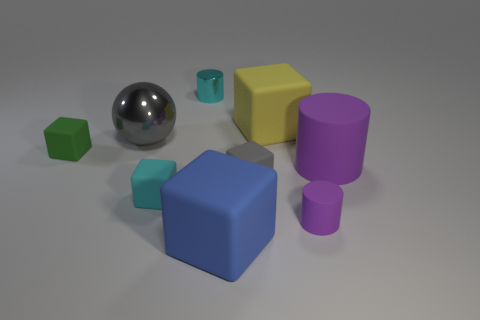Subtract all purple cylinders. How many cylinders are left? 1 Subtract all large yellow blocks. How many blocks are left? 4 Subtract 1 cylinders. How many cylinders are left? 2 Subtract all purple spheres. Subtract all green cylinders. How many spheres are left? 1 Subtract all gray cylinders. How many gray blocks are left? 1 Subtract all small brown shiny things. Subtract all tiny rubber cubes. How many objects are left? 6 Add 4 small cyan cylinders. How many small cyan cylinders are left? 5 Add 4 tiny matte blocks. How many tiny matte blocks exist? 7 Subtract 0 blue cylinders. How many objects are left? 9 Subtract all cylinders. How many objects are left? 6 